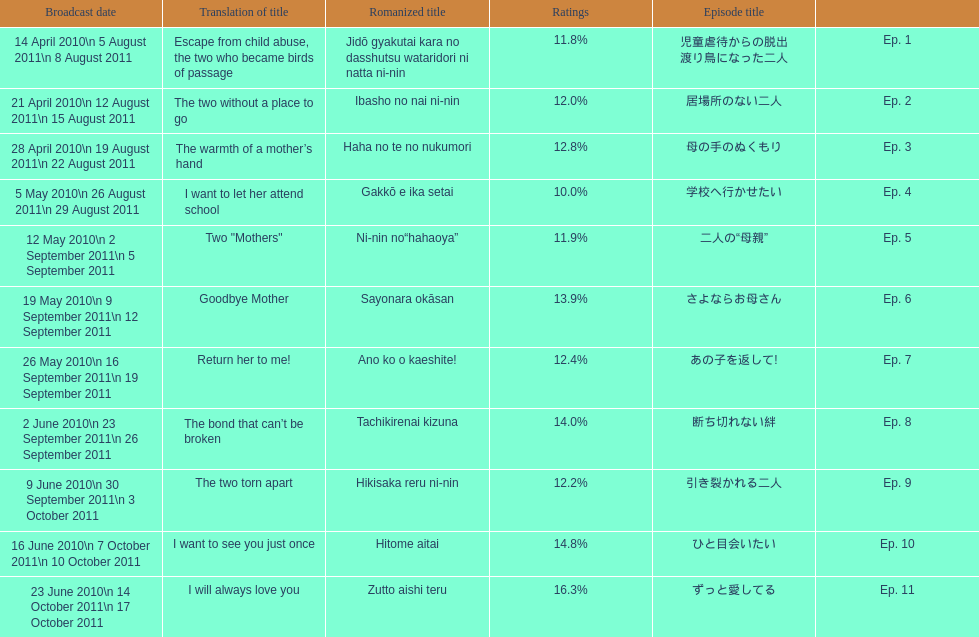What was the name of the next episode after goodbye mother? あの子を返して!. Write the full table. {'header': ['Broadcast date', 'Translation of title', 'Romanized title', 'Ratings', 'Episode title', ''], 'rows': [['14 April 2010\\n 5 August 2011\\n 8 August 2011', 'Escape from child abuse, the two who became birds of passage', 'Jidō gyakutai kara no dasshutsu wataridori ni natta ni-nin', '11.8%', '児童虐待からの脱出 渡り鳥になった二人', 'Ep. 1'], ['21 April 2010\\n 12 August 2011\\n 15 August 2011', 'The two without a place to go', 'Ibasho no nai ni-nin', '12.0%', '居場所のない二人', 'Ep. 2'], ['28 April 2010\\n 19 August 2011\\n 22 August 2011', 'The warmth of a mother’s hand', 'Haha no te no nukumori', '12.8%', '母の手のぬくもり', 'Ep. 3'], ['5 May 2010\\n 26 August 2011\\n 29 August 2011', 'I want to let her attend school', 'Gakkō e ika setai', '10.0%', '学校へ行かせたい', 'Ep. 4'], ['12 May 2010\\n 2 September 2011\\n 5 September 2011', 'Two "Mothers"', 'Ni-nin no“hahaoya”', '11.9%', '二人の“母親”', 'Ep. 5'], ['19 May 2010\\n 9 September 2011\\n 12 September 2011', 'Goodbye Mother', 'Sayonara okāsan', '13.9%', 'さよならお母さん', 'Ep. 6'], ['26 May 2010\\n 16 September 2011\\n 19 September 2011', 'Return her to me!', 'Ano ko o kaeshite!', '12.4%', 'あの子を返して!', 'Ep. 7'], ['2 June 2010\\n 23 September 2011\\n 26 September 2011', 'The bond that can’t be broken', 'Tachikirenai kizuna', '14.0%', '断ち切れない絆', 'Ep. 8'], ['9 June 2010\\n 30 September 2011\\n 3 October 2011', 'The two torn apart', 'Hikisaka reru ni-nin', '12.2%', '引き裂かれる二人', 'Ep. 9'], ['16 June 2010\\n 7 October 2011\\n 10 October 2011', 'I want to see you just once', 'Hitome aitai', '14.8%', 'ひと目会いたい', 'Ep. 10'], ['23 June 2010\\n 14 October 2011\\n 17 October 2011', 'I will always love you', 'Zutto aishi teru', '16.3%', 'ずっと愛してる', 'Ep. 11']]} 